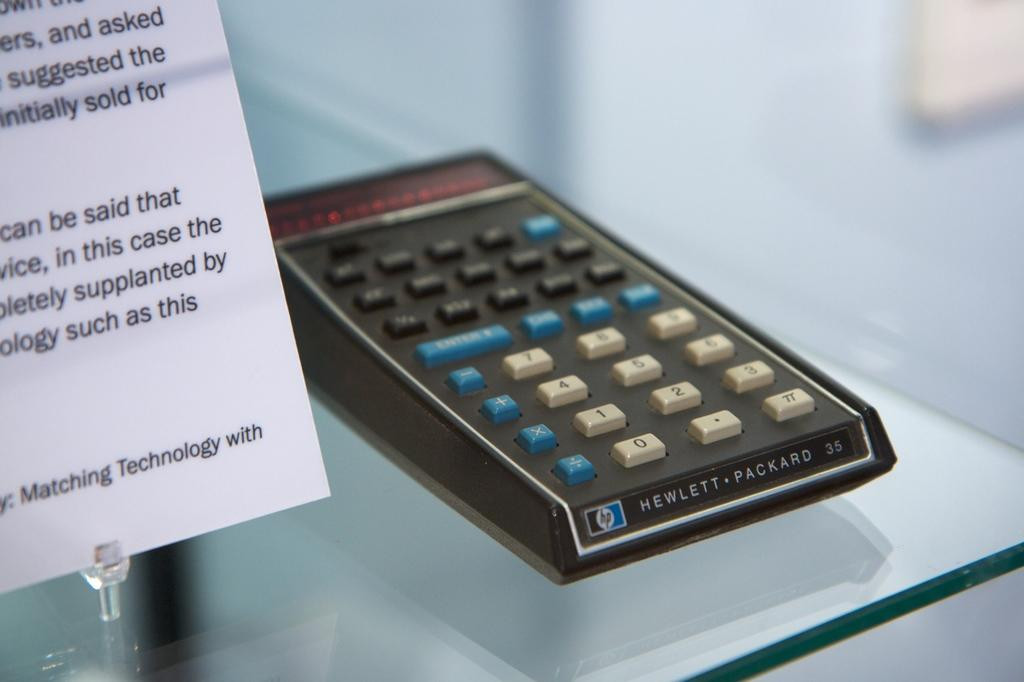What is the main object on the glass table in the image? There is a device on a glass table in the image. Can you describe the device? The device has buttons and text. What is located to the left of the device? There is a paper with text to the left of the device. What type of celery is being used as a part of the device in the image? There is no celery present in the image, nor is it being used as a part of the device. 